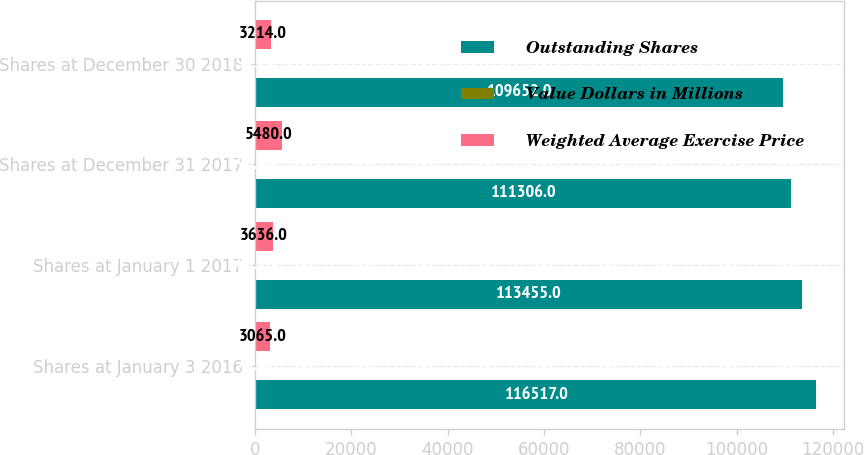Convert chart. <chart><loc_0><loc_0><loc_500><loc_500><stacked_bar_chart><ecel><fcel>Shares at January 3 2016<fcel>Shares at January 1 2017<fcel>Shares at December 31 2017<fcel>Shares at December 30 2018<nl><fcel>Outstanding Shares<fcel>116517<fcel>113455<fcel>111306<fcel>109652<nl><fcel>Value Dollars in Millions<fcel>76.41<fcel>83.16<fcel>90.48<fcel>98.29<nl><fcel>Weighted Average Exercise Price<fcel>3065<fcel>3636<fcel>5480<fcel>3214<nl></chart> 